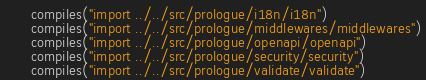Convert code to text. <code><loc_0><loc_0><loc_500><loc_500><_Nim_>      compiles("import ../../src/prologue/i18n/i18n")
      compiles("import ../../src/prologue/middlewares/middlewares")
      compiles("import ../../src/prologue/openapi/openapi")
      compiles("import ../../src/prologue/security/security")
      compiles("import ../../src/prologue/validate/validate")
</code> 